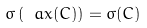Convert formula to latex. <formula><loc_0><loc_0><loc_500><loc_500>\sigma \left ( \ a x ( C ) \right ) = \sigma ( C )</formula> 